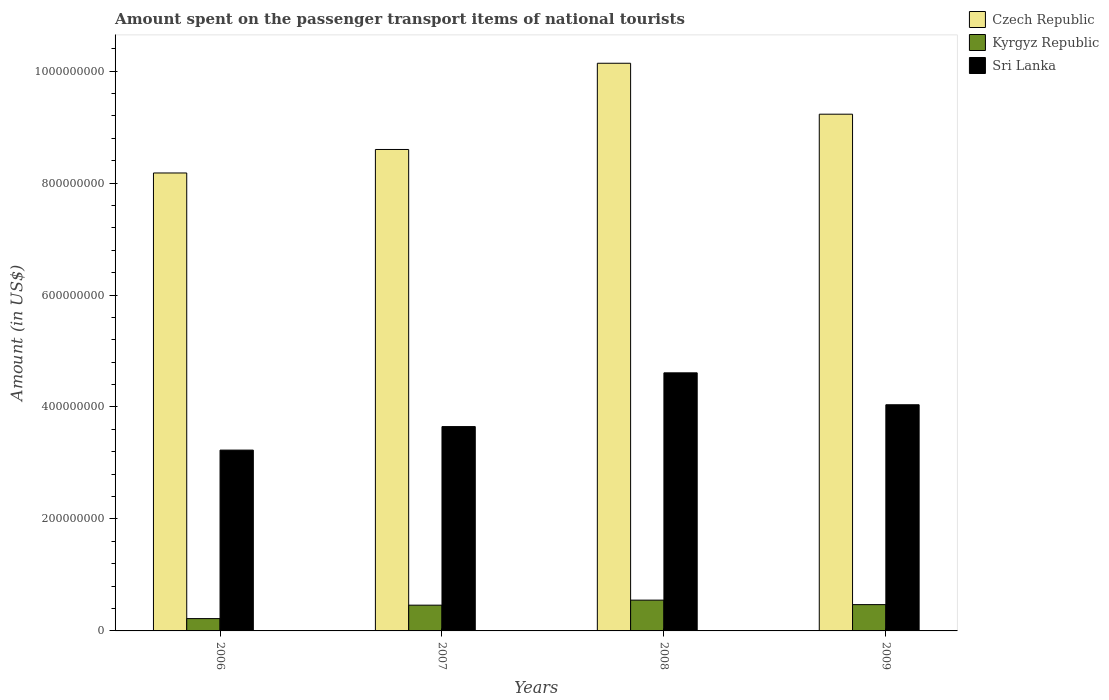How many groups of bars are there?
Make the answer very short. 4. Are the number of bars per tick equal to the number of legend labels?
Your answer should be very brief. Yes. Are the number of bars on each tick of the X-axis equal?
Ensure brevity in your answer.  Yes. How many bars are there on the 4th tick from the left?
Provide a succinct answer. 3. How many bars are there on the 3rd tick from the right?
Your response must be concise. 3. What is the amount spent on the passenger transport items of national tourists in Kyrgyz Republic in 2007?
Provide a short and direct response. 4.60e+07. Across all years, what is the maximum amount spent on the passenger transport items of national tourists in Sri Lanka?
Ensure brevity in your answer.  4.61e+08. Across all years, what is the minimum amount spent on the passenger transport items of national tourists in Sri Lanka?
Your answer should be very brief. 3.23e+08. In which year was the amount spent on the passenger transport items of national tourists in Kyrgyz Republic maximum?
Offer a terse response. 2008. What is the total amount spent on the passenger transport items of national tourists in Kyrgyz Republic in the graph?
Ensure brevity in your answer.  1.70e+08. What is the difference between the amount spent on the passenger transport items of national tourists in Czech Republic in 2006 and that in 2009?
Provide a short and direct response. -1.05e+08. What is the difference between the amount spent on the passenger transport items of national tourists in Kyrgyz Republic in 2008 and the amount spent on the passenger transport items of national tourists in Sri Lanka in 2006?
Offer a terse response. -2.68e+08. What is the average amount spent on the passenger transport items of national tourists in Czech Republic per year?
Ensure brevity in your answer.  9.04e+08. In the year 2006, what is the difference between the amount spent on the passenger transport items of national tourists in Czech Republic and amount spent on the passenger transport items of national tourists in Sri Lanka?
Your answer should be very brief. 4.95e+08. In how many years, is the amount spent on the passenger transport items of national tourists in Czech Republic greater than 920000000 US$?
Ensure brevity in your answer.  2. What is the difference between the highest and the second highest amount spent on the passenger transport items of national tourists in Czech Republic?
Provide a succinct answer. 9.10e+07. What is the difference between the highest and the lowest amount spent on the passenger transport items of national tourists in Sri Lanka?
Offer a terse response. 1.38e+08. Is the sum of the amount spent on the passenger transport items of national tourists in Kyrgyz Republic in 2007 and 2009 greater than the maximum amount spent on the passenger transport items of national tourists in Czech Republic across all years?
Offer a terse response. No. What does the 3rd bar from the left in 2006 represents?
Provide a succinct answer. Sri Lanka. What does the 3rd bar from the right in 2009 represents?
Provide a succinct answer. Czech Republic. How many bars are there?
Provide a succinct answer. 12. What is the difference between two consecutive major ticks on the Y-axis?
Offer a terse response. 2.00e+08. Are the values on the major ticks of Y-axis written in scientific E-notation?
Offer a terse response. No. Does the graph contain any zero values?
Ensure brevity in your answer.  No. Does the graph contain grids?
Offer a terse response. No. Where does the legend appear in the graph?
Offer a very short reply. Top right. What is the title of the graph?
Offer a terse response. Amount spent on the passenger transport items of national tourists. Does "American Samoa" appear as one of the legend labels in the graph?
Your response must be concise. No. What is the label or title of the X-axis?
Make the answer very short. Years. What is the label or title of the Y-axis?
Your response must be concise. Amount (in US$). What is the Amount (in US$) in Czech Republic in 2006?
Ensure brevity in your answer.  8.18e+08. What is the Amount (in US$) in Kyrgyz Republic in 2006?
Offer a very short reply. 2.20e+07. What is the Amount (in US$) in Sri Lanka in 2006?
Offer a terse response. 3.23e+08. What is the Amount (in US$) of Czech Republic in 2007?
Provide a succinct answer. 8.60e+08. What is the Amount (in US$) of Kyrgyz Republic in 2007?
Keep it short and to the point. 4.60e+07. What is the Amount (in US$) in Sri Lanka in 2007?
Provide a short and direct response. 3.65e+08. What is the Amount (in US$) in Czech Republic in 2008?
Give a very brief answer. 1.01e+09. What is the Amount (in US$) in Kyrgyz Republic in 2008?
Offer a very short reply. 5.50e+07. What is the Amount (in US$) of Sri Lanka in 2008?
Your answer should be compact. 4.61e+08. What is the Amount (in US$) in Czech Republic in 2009?
Provide a succinct answer. 9.23e+08. What is the Amount (in US$) in Kyrgyz Republic in 2009?
Provide a short and direct response. 4.70e+07. What is the Amount (in US$) of Sri Lanka in 2009?
Keep it short and to the point. 4.04e+08. Across all years, what is the maximum Amount (in US$) in Czech Republic?
Give a very brief answer. 1.01e+09. Across all years, what is the maximum Amount (in US$) of Kyrgyz Republic?
Offer a terse response. 5.50e+07. Across all years, what is the maximum Amount (in US$) in Sri Lanka?
Your answer should be very brief. 4.61e+08. Across all years, what is the minimum Amount (in US$) in Czech Republic?
Provide a short and direct response. 8.18e+08. Across all years, what is the minimum Amount (in US$) of Kyrgyz Republic?
Ensure brevity in your answer.  2.20e+07. Across all years, what is the minimum Amount (in US$) in Sri Lanka?
Offer a terse response. 3.23e+08. What is the total Amount (in US$) in Czech Republic in the graph?
Your response must be concise. 3.62e+09. What is the total Amount (in US$) in Kyrgyz Republic in the graph?
Ensure brevity in your answer.  1.70e+08. What is the total Amount (in US$) of Sri Lanka in the graph?
Keep it short and to the point. 1.55e+09. What is the difference between the Amount (in US$) of Czech Republic in 2006 and that in 2007?
Offer a terse response. -4.20e+07. What is the difference between the Amount (in US$) in Kyrgyz Republic in 2006 and that in 2007?
Offer a very short reply. -2.40e+07. What is the difference between the Amount (in US$) of Sri Lanka in 2006 and that in 2007?
Provide a succinct answer. -4.20e+07. What is the difference between the Amount (in US$) in Czech Republic in 2006 and that in 2008?
Keep it short and to the point. -1.96e+08. What is the difference between the Amount (in US$) of Kyrgyz Republic in 2006 and that in 2008?
Your answer should be compact. -3.30e+07. What is the difference between the Amount (in US$) in Sri Lanka in 2006 and that in 2008?
Keep it short and to the point. -1.38e+08. What is the difference between the Amount (in US$) of Czech Republic in 2006 and that in 2009?
Your answer should be very brief. -1.05e+08. What is the difference between the Amount (in US$) in Kyrgyz Republic in 2006 and that in 2009?
Give a very brief answer. -2.50e+07. What is the difference between the Amount (in US$) of Sri Lanka in 2006 and that in 2009?
Give a very brief answer. -8.10e+07. What is the difference between the Amount (in US$) of Czech Republic in 2007 and that in 2008?
Ensure brevity in your answer.  -1.54e+08. What is the difference between the Amount (in US$) of Kyrgyz Republic in 2007 and that in 2008?
Offer a very short reply. -9.00e+06. What is the difference between the Amount (in US$) in Sri Lanka in 2007 and that in 2008?
Give a very brief answer. -9.60e+07. What is the difference between the Amount (in US$) of Czech Republic in 2007 and that in 2009?
Your answer should be very brief. -6.30e+07. What is the difference between the Amount (in US$) in Kyrgyz Republic in 2007 and that in 2009?
Your response must be concise. -1.00e+06. What is the difference between the Amount (in US$) of Sri Lanka in 2007 and that in 2009?
Your answer should be very brief. -3.90e+07. What is the difference between the Amount (in US$) of Czech Republic in 2008 and that in 2009?
Your answer should be very brief. 9.10e+07. What is the difference between the Amount (in US$) of Kyrgyz Republic in 2008 and that in 2009?
Offer a terse response. 8.00e+06. What is the difference between the Amount (in US$) in Sri Lanka in 2008 and that in 2009?
Give a very brief answer. 5.70e+07. What is the difference between the Amount (in US$) in Czech Republic in 2006 and the Amount (in US$) in Kyrgyz Republic in 2007?
Make the answer very short. 7.72e+08. What is the difference between the Amount (in US$) in Czech Republic in 2006 and the Amount (in US$) in Sri Lanka in 2007?
Your answer should be compact. 4.53e+08. What is the difference between the Amount (in US$) in Kyrgyz Republic in 2006 and the Amount (in US$) in Sri Lanka in 2007?
Provide a succinct answer. -3.43e+08. What is the difference between the Amount (in US$) of Czech Republic in 2006 and the Amount (in US$) of Kyrgyz Republic in 2008?
Offer a very short reply. 7.63e+08. What is the difference between the Amount (in US$) in Czech Republic in 2006 and the Amount (in US$) in Sri Lanka in 2008?
Your answer should be very brief. 3.57e+08. What is the difference between the Amount (in US$) of Kyrgyz Republic in 2006 and the Amount (in US$) of Sri Lanka in 2008?
Make the answer very short. -4.39e+08. What is the difference between the Amount (in US$) in Czech Republic in 2006 and the Amount (in US$) in Kyrgyz Republic in 2009?
Your answer should be compact. 7.71e+08. What is the difference between the Amount (in US$) of Czech Republic in 2006 and the Amount (in US$) of Sri Lanka in 2009?
Provide a short and direct response. 4.14e+08. What is the difference between the Amount (in US$) of Kyrgyz Republic in 2006 and the Amount (in US$) of Sri Lanka in 2009?
Offer a very short reply. -3.82e+08. What is the difference between the Amount (in US$) in Czech Republic in 2007 and the Amount (in US$) in Kyrgyz Republic in 2008?
Make the answer very short. 8.05e+08. What is the difference between the Amount (in US$) in Czech Republic in 2007 and the Amount (in US$) in Sri Lanka in 2008?
Provide a short and direct response. 3.99e+08. What is the difference between the Amount (in US$) in Kyrgyz Republic in 2007 and the Amount (in US$) in Sri Lanka in 2008?
Make the answer very short. -4.15e+08. What is the difference between the Amount (in US$) in Czech Republic in 2007 and the Amount (in US$) in Kyrgyz Republic in 2009?
Keep it short and to the point. 8.13e+08. What is the difference between the Amount (in US$) in Czech Republic in 2007 and the Amount (in US$) in Sri Lanka in 2009?
Your answer should be very brief. 4.56e+08. What is the difference between the Amount (in US$) of Kyrgyz Republic in 2007 and the Amount (in US$) of Sri Lanka in 2009?
Make the answer very short. -3.58e+08. What is the difference between the Amount (in US$) in Czech Republic in 2008 and the Amount (in US$) in Kyrgyz Republic in 2009?
Your answer should be compact. 9.67e+08. What is the difference between the Amount (in US$) in Czech Republic in 2008 and the Amount (in US$) in Sri Lanka in 2009?
Keep it short and to the point. 6.10e+08. What is the difference between the Amount (in US$) in Kyrgyz Republic in 2008 and the Amount (in US$) in Sri Lanka in 2009?
Offer a terse response. -3.49e+08. What is the average Amount (in US$) in Czech Republic per year?
Give a very brief answer. 9.04e+08. What is the average Amount (in US$) of Kyrgyz Republic per year?
Give a very brief answer. 4.25e+07. What is the average Amount (in US$) of Sri Lanka per year?
Your answer should be compact. 3.88e+08. In the year 2006, what is the difference between the Amount (in US$) in Czech Republic and Amount (in US$) in Kyrgyz Republic?
Your answer should be compact. 7.96e+08. In the year 2006, what is the difference between the Amount (in US$) of Czech Republic and Amount (in US$) of Sri Lanka?
Your answer should be compact. 4.95e+08. In the year 2006, what is the difference between the Amount (in US$) in Kyrgyz Republic and Amount (in US$) in Sri Lanka?
Your answer should be very brief. -3.01e+08. In the year 2007, what is the difference between the Amount (in US$) in Czech Republic and Amount (in US$) in Kyrgyz Republic?
Offer a very short reply. 8.14e+08. In the year 2007, what is the difference between the Amount (in US$) of Czech Republic and Amount (in US$) of Sri Lanka?
Provide a succinct answer. 4.95e+08. In the year 2007, what is the difference between the Amount (in US$) in Kyrgyz Republic and Amount (in US$) in Sri Lanka?
Your answer should be compact. -3.19e+08. In the year 2008, what is the difference between the Amount (in US$) of Czech Republic and Amount (in US$) of Kyrgyz Republic?
Offer a terse response. 9.59e+08. In the year 2008, what is the difference between the Amount (in US$) in Czech Republic and Amount (in US$) in Sri Lanka?
Your answer should be compact. 5.53e+08. In the year 2008, what is the difference between the Amount (in US$) in Kyrgyz Republic and Amount (in US$) in Sri Lanka?
Give a very brief answer. -4.06e+08. In the year 2009, what is the difference between the Amount (in US$) of Czech Republic and Amount (in US$) of Kyrgyz Republic?
Your answer should be very brief. 8.76e+08. In the year 2009, what is the difference between the Amount (in US$) of Czech Republic and Amount (in US$) of Sri Lanka?
Offer a very short reply. 5.19e+08. In the year 2009, what is the difference between the Amount (in US$) in Kyrgyz Republic and Amount (in US$) in Sri Lanka?
Offer a very short reply. -3.57e+08. What is the ratio of the Amount (in US$) of Czech Republic in 2006 to that in 2007?
Provide a short and direct response. 0.95. What is the ratio of the Amount (in US$) in Kyrgyz Republic in 2006 to that in 2007?
Offer a terse response. 0.48. What is the ratio of the Amount (in US$) in Sri Lanka in 2006 to that in 2007?
Your answer should be compact. 0.88. What is the ratio of the Amount (in US$) in Czech Republic in 2006 to that in 2008?
Give a very brief answer. 0.81. What is the ratio of the Amount (in US$) in Kyrgyz Republic in 2006 to that in 2008?
Ensure brevity in your answer.  0.4. What is the ratio of the Amount (in US$) of Sri Lanka in 2006 to that in 2008?
Your answer should be very brief. 0.7. What is the ratio of the Amount (in US$) in Czech Republic in 2006 to that in 2009?
Provide a succinct answer. 0.89. What is the ratio of the Amount (in US$) of Kyrgyz Republic in 2006 to that in 2009?
Give a very brief answer. 0.47. What is the ratio of the Amount (in US$) of Sri Lanka in 2006 to that in 2009?
Ensure brevity in your answer.  0.8. What is the ratio of the Amount (in US$) of Czech Republic in 2007 to that in 2008?
Provide a succinct answer. 0.85. What is the ratio of the Amount (in US$) in Kyrgyz Republic in 2007 to that in 2008?
Offer a terse response. 0.84. What is the ratio of the Amount (in US$) in Sri Lanka in 2007 to that in 2008?
Your answer should be compact. 0.79. What is the ratio of the Amount (in US$) in Czech Republic in 2007 to that in 2009?
Provide a short and direct response. 0.93. What is the ratio of the Amount (in US$) in Kyrgyz Republic in 2007 to that in 2009?
Provide a short and direct response. 0.98. What is the ratio of the Amount (in US$) of Sri Lanka in 2007 to that in 2009?
Provide a short and direct response. 0.9. What is the ratio of the Amount (in US$) of Czech Republic in 2008 to that in 2009?
Provide a succinct answer. 1.1. What is the ratio of the Amount (in US$) in Kyrgyz Republic in 2008 to that in 2009?
Offer a very short reply. 1.17. What is the ratio of the Amount (in US$) in Sri Lanka in 2008 to that in 2009?
Your response must be concise. 1.14. What is the difference between the highest and the second highest Amount (in US$) of Czech Republic?
Keep it short and to the point. 9.10e+07. What is the difference between the highest and the second highest Amount (in US$) of Kyrgyz Republic?
Give a very brief answer. 8.00e+06. What is the difference between the highest and the second highest Amount (in US$) of Sri Lanka?
Ensure brevity in your answer.  5.70e+07. What is the difference between the highest and the lowest Amount (in US$) of Czech Republic?
Ensure brevity in your answer.  1.96e+08. What is the difference between the highest and the lowest Amount (in US$) in Kyrgyz Republic?
Make the answer very short. 3.30e+07. What is the difference between the highest and the lowest Amount (in US$) in Sri Lanka?
Offer a terse response. 1.38e+08. 